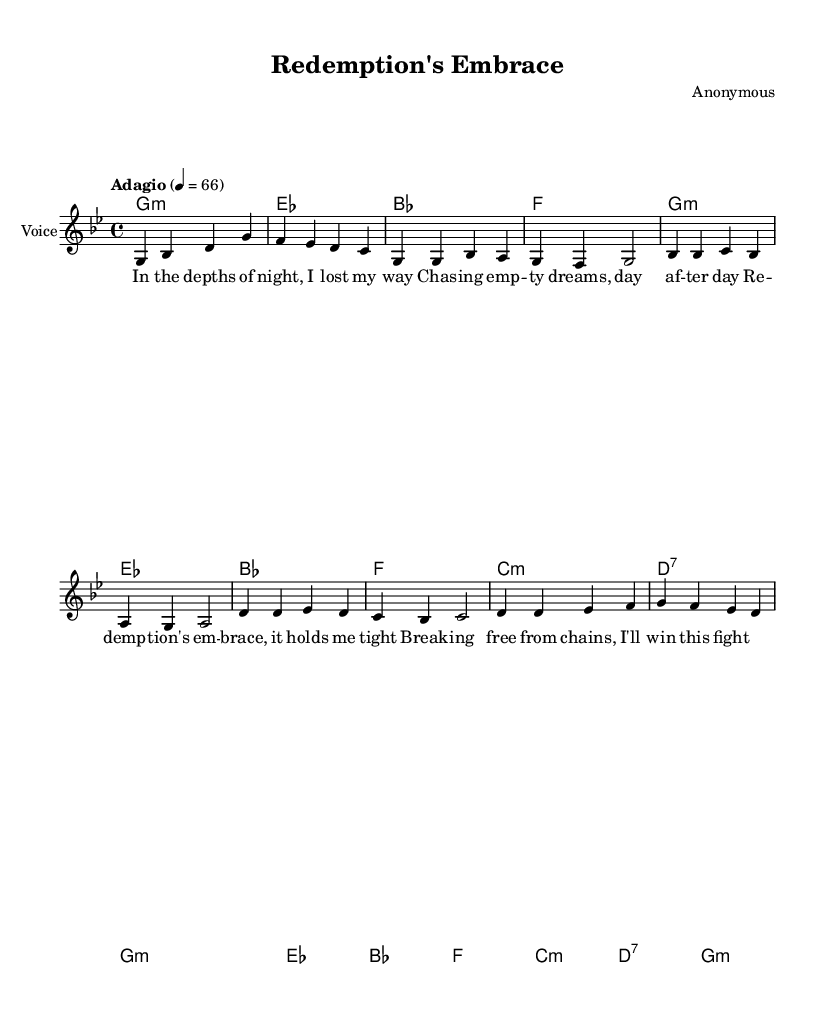What is the key signature of this music? The key signature is G minor, which has two flats (B♭ and E♭). This is indicated at the beginning of the score.
Answer: G minor What is the time signature of the piece? The time signature is 4/4, which means there are four beats in each measure and the quarter note gets one beat. This is specified next to the key signature.
Answer: 4/4 What is the tempo marking of the composition? The tempo marking is "Adagio," indicating a slow tempo. It's noted above the staff in the score.
Answer: Adagio How many measures are in the chorus section? The chorus section consists of four measures, as evidenced by the grouping of music notes that correspond to the text of the chorus.
Answer: Four What is the mood conveyed in the lyrics of the song? The lyrics convey a sense of struggle and hope, highlighting the journey towards redemption and overcoming challenges associated with addiction. This is clear from phrases like "redemption's embrace" and "breaking free from chains."
Answer: Hopeful Which musical technique is used in the introduction? The introduction employs a melodic motif that sets the stage for the emotional narrative of the song, allowing the listener to feel the depth of the theme immediately. This is evident in the way the melody introduces the key themes.
Answer: Melodic motif 